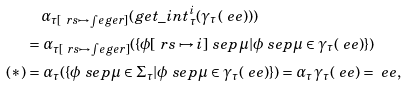Convert formula to latex. <formula><loc_0><loc_0><loc_500><loc_500>& \quad \alpha _ { \tau [ \ r s \mapsto \int e g e r ] } ( g e t \_ i n t ^ { i } _ { \tau } ( \gamma _ { \tau } ( \ e e ) ) ) \\ & = \alpha _ { \tau [ \ r s \mapsto \int e g e r ] } ( \{ \phi [ \ r s \mapsto i ] \ s e p \mu | \phi \ s e p \mu \in \gamma _ { \tau } ( \ e e ) \} ) \\ \text {($*$)} & = \alpha _ { \tau } ( \{ \phi \ s e p \mu \in \Sigma _ { \tau } | \phi \ s e p \mu \in \gamma _ { \tau } ( \ e e ) \} ) = \alpha _ { \tau } \gamma _ { \tau } ( \ e e ) = \ e e ,</formula> 